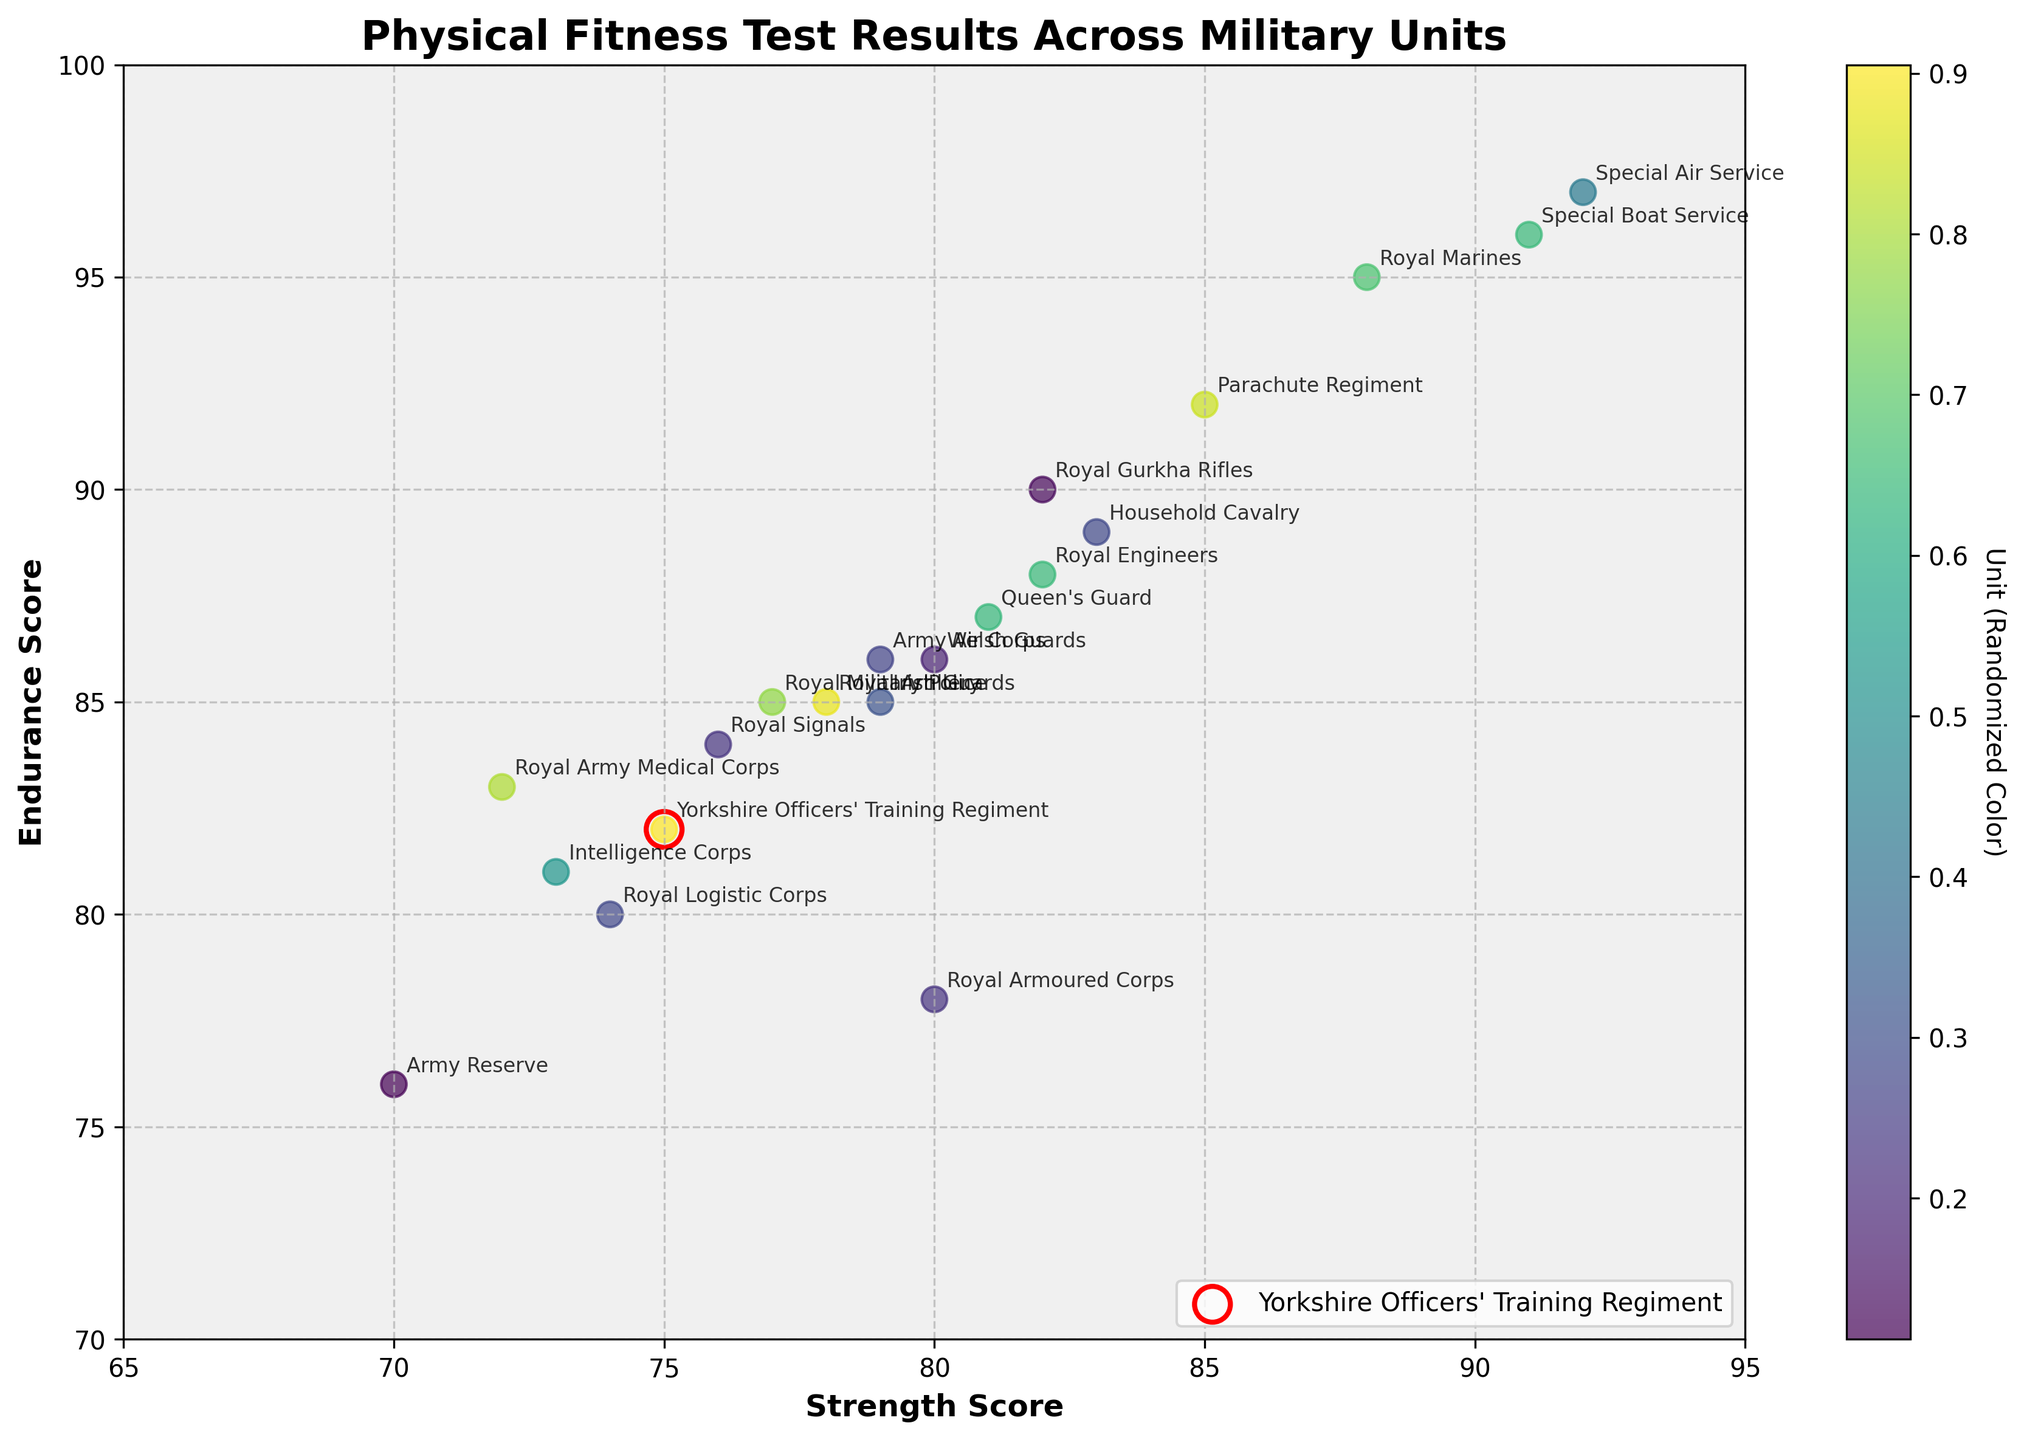How many military units are represented in the plot? Count the number of distinct units provided in the data table.
Answer: 20 What are the axis labels of the plot? The x-axis is labeled 'Strength Score' and the y-axis is labeled 'Endurance Score', as shown in the plot.
Answer: Strength Score and Endurance Score Which unit has the highest strength score, and what is it? The plot shows the Special Air Service has the highest strength score, indicated by the data point furthest to the right. According to the data, this score is 92.
Answer: Special Air Service, 92 What are the scores for the Yorkshire Officers' Training Regiment? The Yorkshire Officers' Training Regiment has a Strength Score of 75 and an Endurance Score of 82. These scores are highlighted with a red circle on the plot.
Answer: 75 strength, 82 endurance Which unit has the highest endurance score, and what is it? The plot shows the Special Air Service has the highest endurance score, indicated by the topmost data point. According to the data, this score is 97.
Answer: Special Air Service, 97 Which unit has a lower endurance score, the Royal Logistic Corps or the Irish Guards? Compare the Endurance Scores of both units on the plot. The Royal Logistic Corps has an Endurance Score of 80, and the Irish Guards have a score of 85.
Answer: Royal Logistic Corps If you calculate the average strength score and average endurance score, do they fall close to any particular unit's scores? Calculate the averages: (75+88+85+82+80+78+82+76+79+74+72+73+92+91+77+70+81+83+80+79)/20 = 80 for strength; (82+95+92+90+78+85+88+84+86+80+83+81+97+96+85+76+87+89+86+85)/20 = 86.5 for endurance. The unit closest to these averages is the Welsh Guards (80 strength, 86 endurance).
Answer: Welsh Guards Which unit has a higher strength score but a lower endurance score compared to the Royal Military Police? Identify units with a strength score greater than 77 and an endurance score less than 85. The Royal Armoured Corps (80 strength, 78 endurance) fits this criterion.
Answer: Royal Armoured Corps What is the difference in endurance score between the Royal Marines and the Army Reserve? Subtract the Endurance Score of the Army Reserve from that of the Royal Marines: 95 - 76 = 19.
Answer: 19 How is the Yorkshire Officers' Training Regiment visually distinguished from the other units on the plot? The Yorkshire Officers' Training Regiment's data point is highlighted with a larger circle with a red outline.
Answer: Larger circle with red outline Which units fall within the top right quadrant (Strength Score above 82 and Endurance Score above 87)? Identify data points in the top right quadrant of the plot. These units are the Parachute Regiment, Royal Gurkha Rifles, Special Air Service, Special Boat Service, and Household Cavalry.
Answer: 5 units 